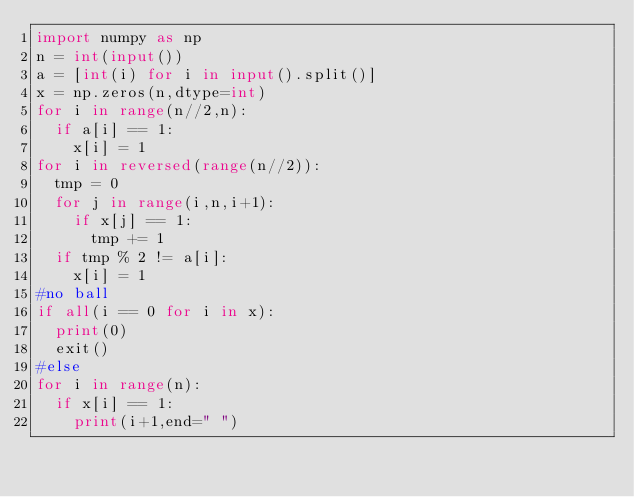Convert code to text. <code><loc_0><loc_0><loc_500><loc_500><_Python_>import numpy as np
n = int(input())
a = [int(i) for i in input().split()]
x = np.zeros(n,dtype=int)
for i in range(n//2,n):
  if a[i] == 1:
    x[i] = 1
for i in reversed(range(n//2)):
  tmp = 0
  for j in range(i,n,i+1):
    if x[j] == 1:
      tmp += 1
  if tmp % 2 != a[i]:
    x[i] = 1
#no ball
if all(i == 0 for i in x):
  print(0)
  exit()
#else
for i in range(n):
  if x[i] == 1:
    print(i+1,end=" ")</code> 